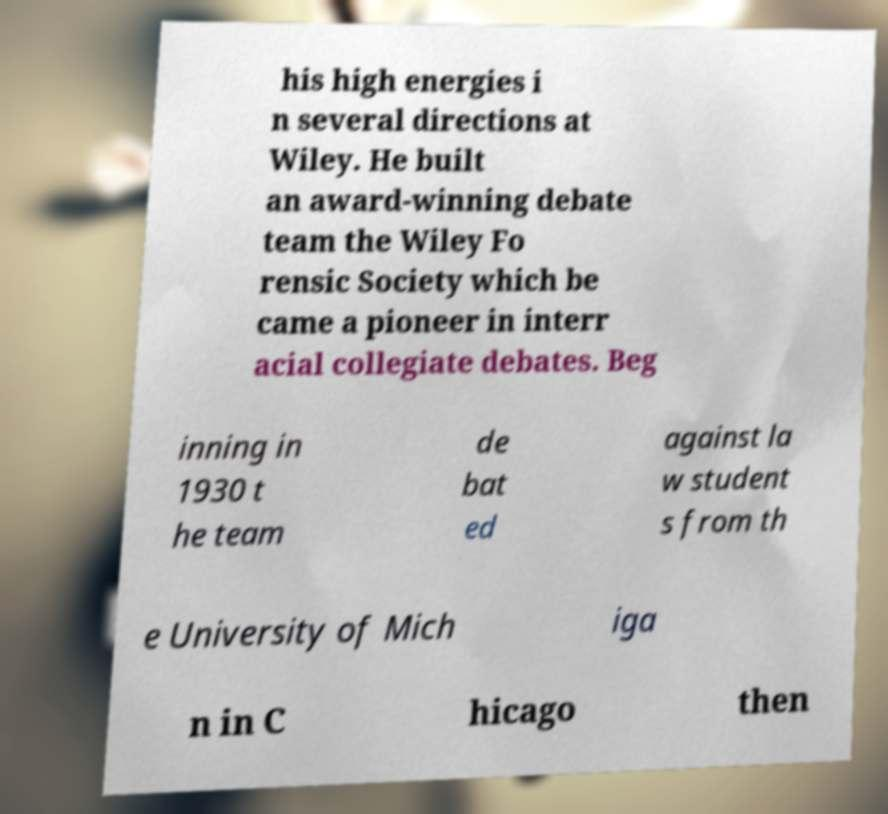Please identify and transcribe the text found in this image. his high energies i n several directions at Wiley. He built an award-winning debate team the Wiley Fo rensic Society which be came a pioneer in interr acial collegiate debates. Beg inning in 1930 t he team de bat ed against la w student s from th e University of Mich iga n in C hicago then 